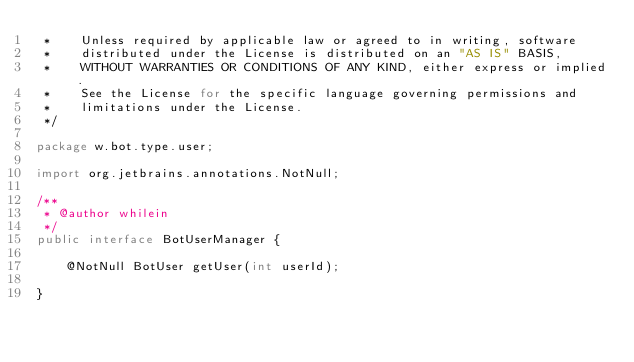Convert code to text. <code><loc_0><loc_0><loc_500><loc_500><_Java_> *    Unless required by applicable law or agreed to in writing, software
 *    distributed under the License is distributed on an "AS IS" BASIS,
 *    WITHOUT WARRANTIES OR CONDITIONS OF ANY KIND, either express or implied.
 *    See the License for the specific language governing permissions and
 *    limitations under the License.
 */

package w.bot.type.user;

import org.jetbrains.annotations.NotNull;

/**
 * @author whilein
 */
public interface BotUserManager {

    @NotNull BotUser getUser(int userId);

}
</code> 